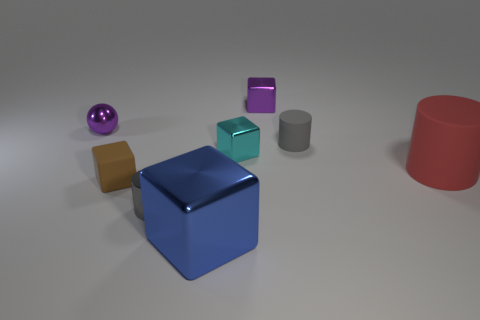What number of brown metallic things have the same size as the cyan metal object? In the image, there are no brown metallic objects that share the same size with the prominent cyan metal cube. 